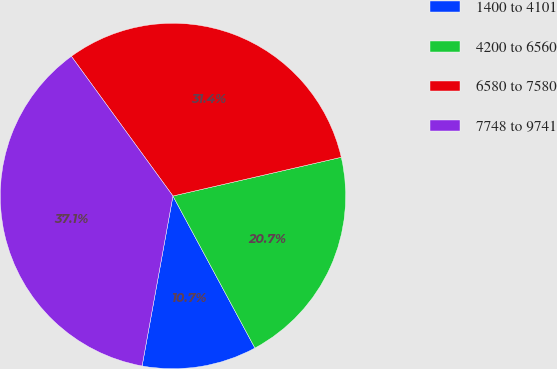Convert chart to OTSL. <chart><loc_0><loc_0><loc_500><loc_500><pie_chart><fcel>1400 to 4101<fcel>4200 to 6560<fcel>6580 to 7580<fcel>7748 to 9741<nl><fcel>10.73%<fcel>20.73%<fcel>31.41%<fcel>37.14%<nl></chart> 